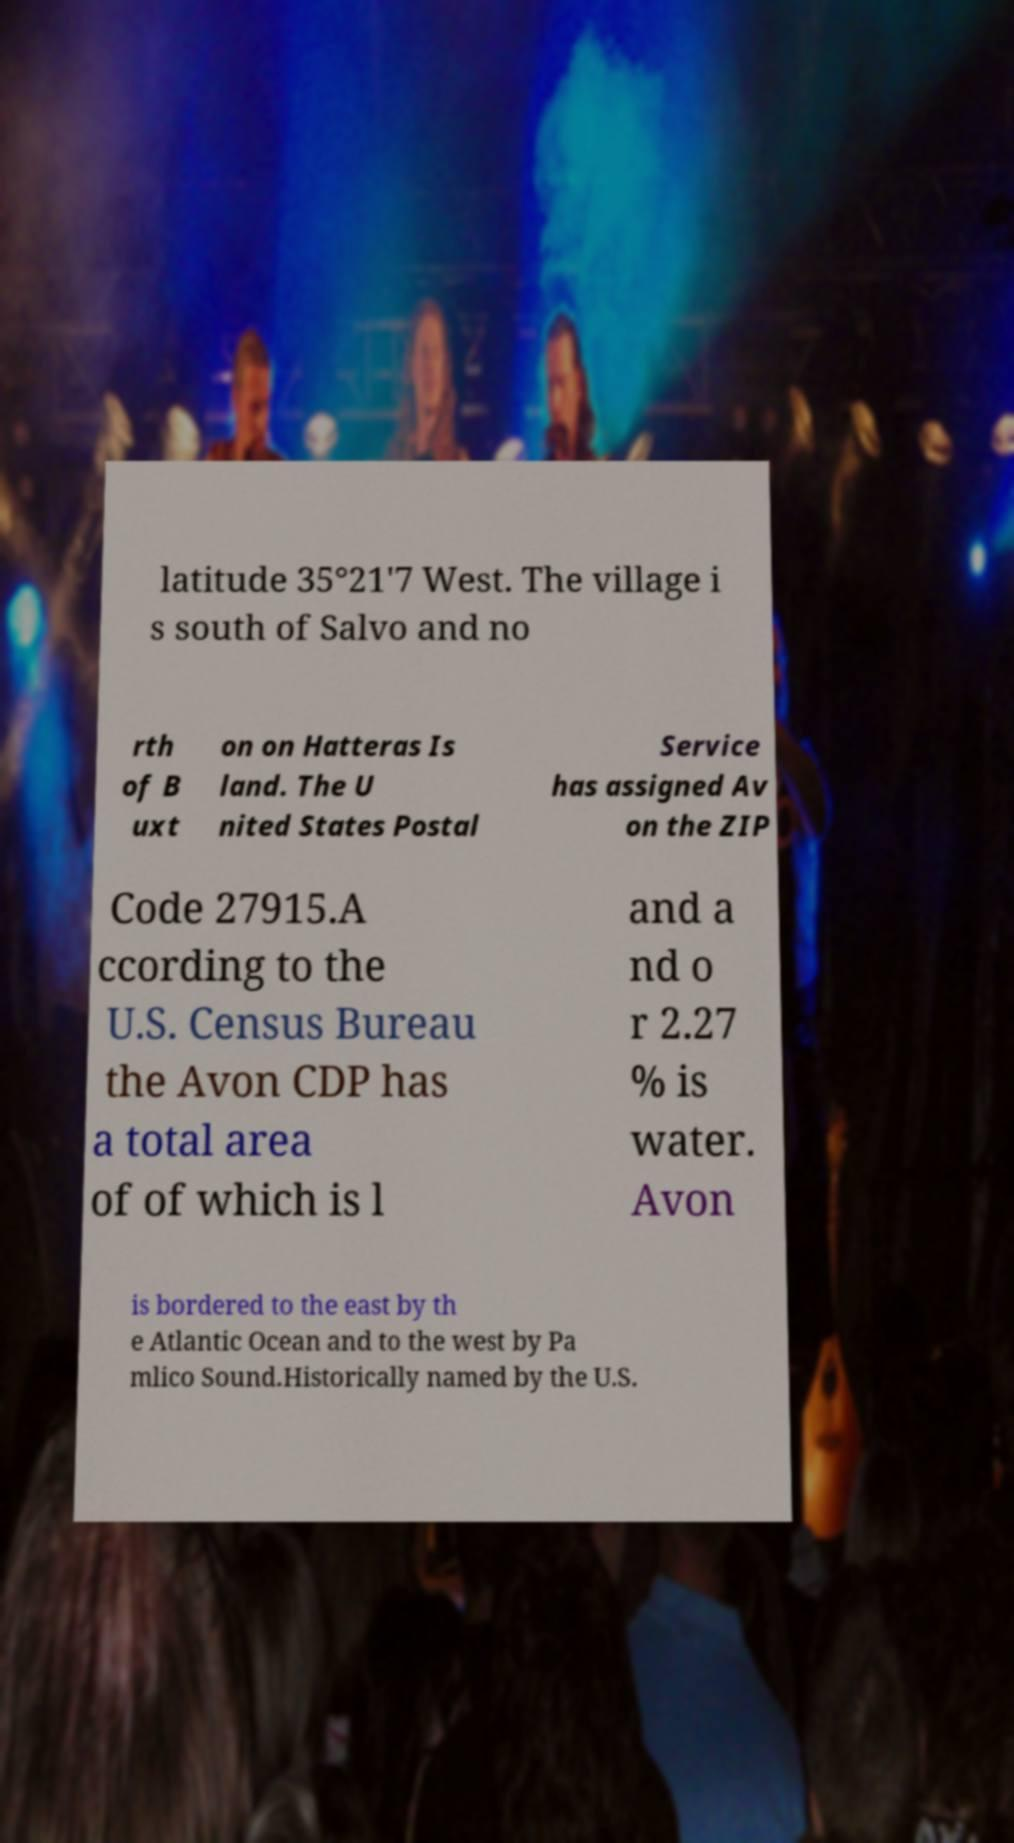For documentation purposes, I need the text within this image transcribed. Could you provide that? latitude 35°21'7 West. The village i s south of Salvo and no rth of B uxt on on Hatteras Is land. The U nited States Postal Service has assigned Av on the ZIP Code 27915.A ccording to the U.S. Census Bureau the Avon CDP has a total area of of which is l and a nd o r 2.27 % is water. Avon is bordered to the east by th e Atlantic Ocean and to the west by Pa mlico Sound.Historically named by the U.S. 